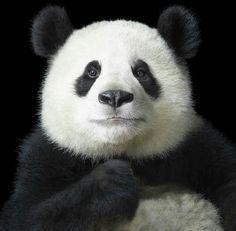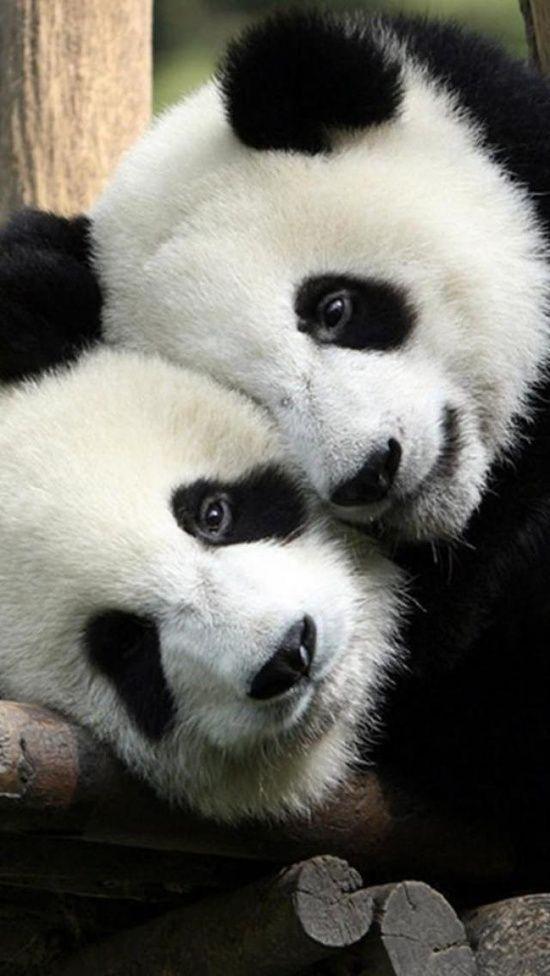The first image is the image on the left, the second image is the image on the right. Assess this claim about the two images: "A panda has its head on the floor in the right image.". Correct or not? Answer yes or no. No. The first image is the image on the left, the second image is the image on the right. For the images shown, is this caption "Two panda faces can be seen, one on top of the other, in one image." true? Answer yes or no. Yes. 